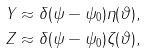Convert formula to latex. <formula><loc_0><loc_0><loc_500><loc_500>Y & \approx \delta ( \psi - \psi _ { 0 } ) \eta ( \vartheta ) , \\ Z & \approx \delta ( \psi - \psi _ { 0 } ) \zeta ( \vartheta ) ,</formula> 